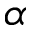<formula> <loc_0><loc_0><loc_500><loc_500>\alpha</formula> 